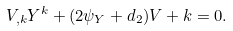Convert formula to latex. <formula><loc_0><loc_0><loc_500><loc_500>V _ { , k } Y ^ { k } + ( 2 \psi _ { Y } + d _ { 2 } ) V + k = 0 .</formula> 